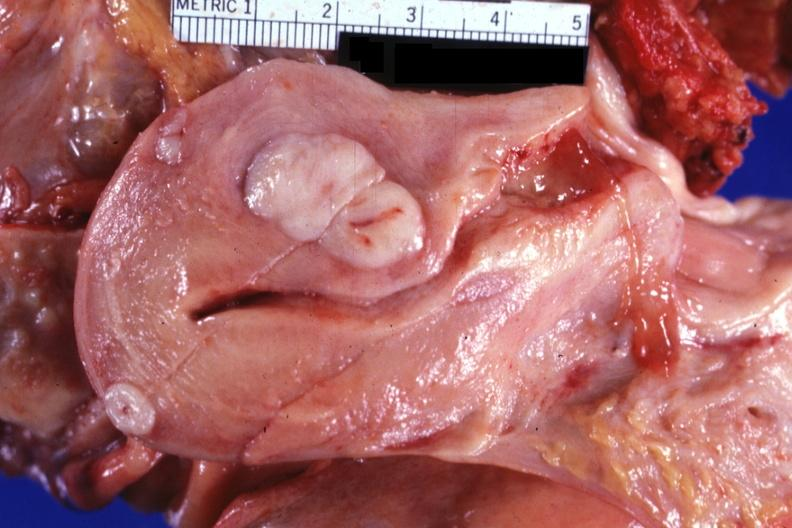s tuberculous peritonitis present?
Answer the question using a single word or phrase. No 